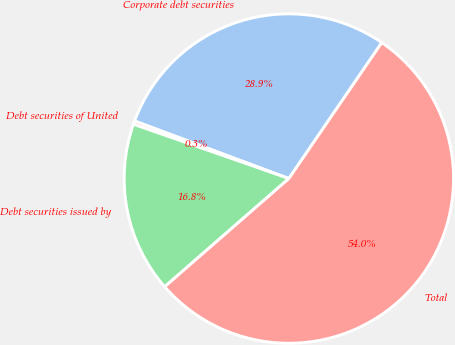Convert chart to OTSL. <chart><loc_0><loc_0><loc_500><loc_500><pie_chart><fcel>Corporate debt securities<fcel>Debt securities of United<fcel>Debt securities issued by<fcel>Total<nl><fcel>28.86%<fcel>0.33%<fcel>16.76%<fcel>54.05%<nl></chart> 